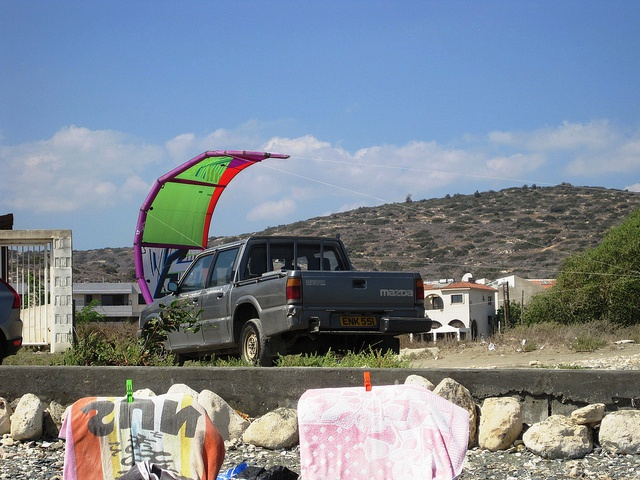Describe the objects in this image and their specific colors. I can see truck in gray, black, darkgray, and blue tones, kite in gray, green, and black tones, and car in gray, black, and maroon tones in this image. 